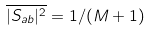<formula> <loc_0><loc_0><loc_500><loc_500>\overline { | S _ { a b } | ^ { 2 } } = 1 / ( M + 1 )</formula> 